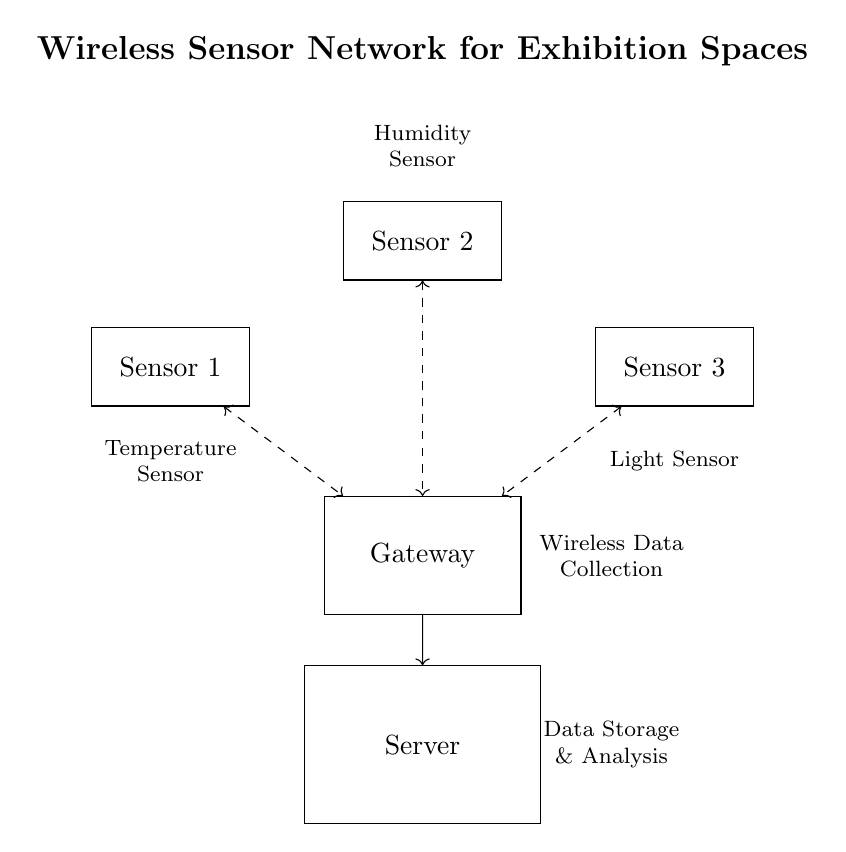What are the types of sensors shown? The diagram shows three types of sensors: a temperature sensor, a humidity sensor, and a light sensor. These are labeled directly on the diagram, providing straightforward identification of each component.
Answer: Temperature, Humidity, Light How many sensor nodes are there? There are three sensor nodes in the circuit, as indicated by the three rectangles labeled as Sensor 1, Sensor 2, and Sensor 3. The count can be deduced by simply looking at the sensor components in the diagram.
Answer: Three What is the function of the gateway? The gateway serves as a centralized device that collects data wirelessly from all the sensor nodes and then transmits this data to the server via a wired connection. Its role is to facilitate communication between wireless sensors and the server.
Answer: Wireless Data Collection Which sensor is connected to the gateway? All three sensors are connected to the gateway, which has dashed arrows indicating wireless communication lines from each sensor to the gateway. This visual representation makes it clear that they all report data to the central gateway.
Answer: All sensors How is the server connected to the gateway? The server is connected to the gateway through a wired connection, depicted by a solid arrow. This indicates that the data from the gateway is transferred to the server for storage and analysis, showing the data flow within the system.
Answer: Wired connection What type of data collection is indicated? The diagram illustrates wireless data collection, as demonstrated by the dashed lines representing the communication between the sensor nodes and the gateway. This type of data collection minimizes wiring and allows for flexible sensor placements in exhibition spaces.
Answer: Wireless Data Collection 